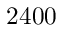<formula> <loc_0><loc_0><loc_500><loc_500>2 4 0 0</formula> 